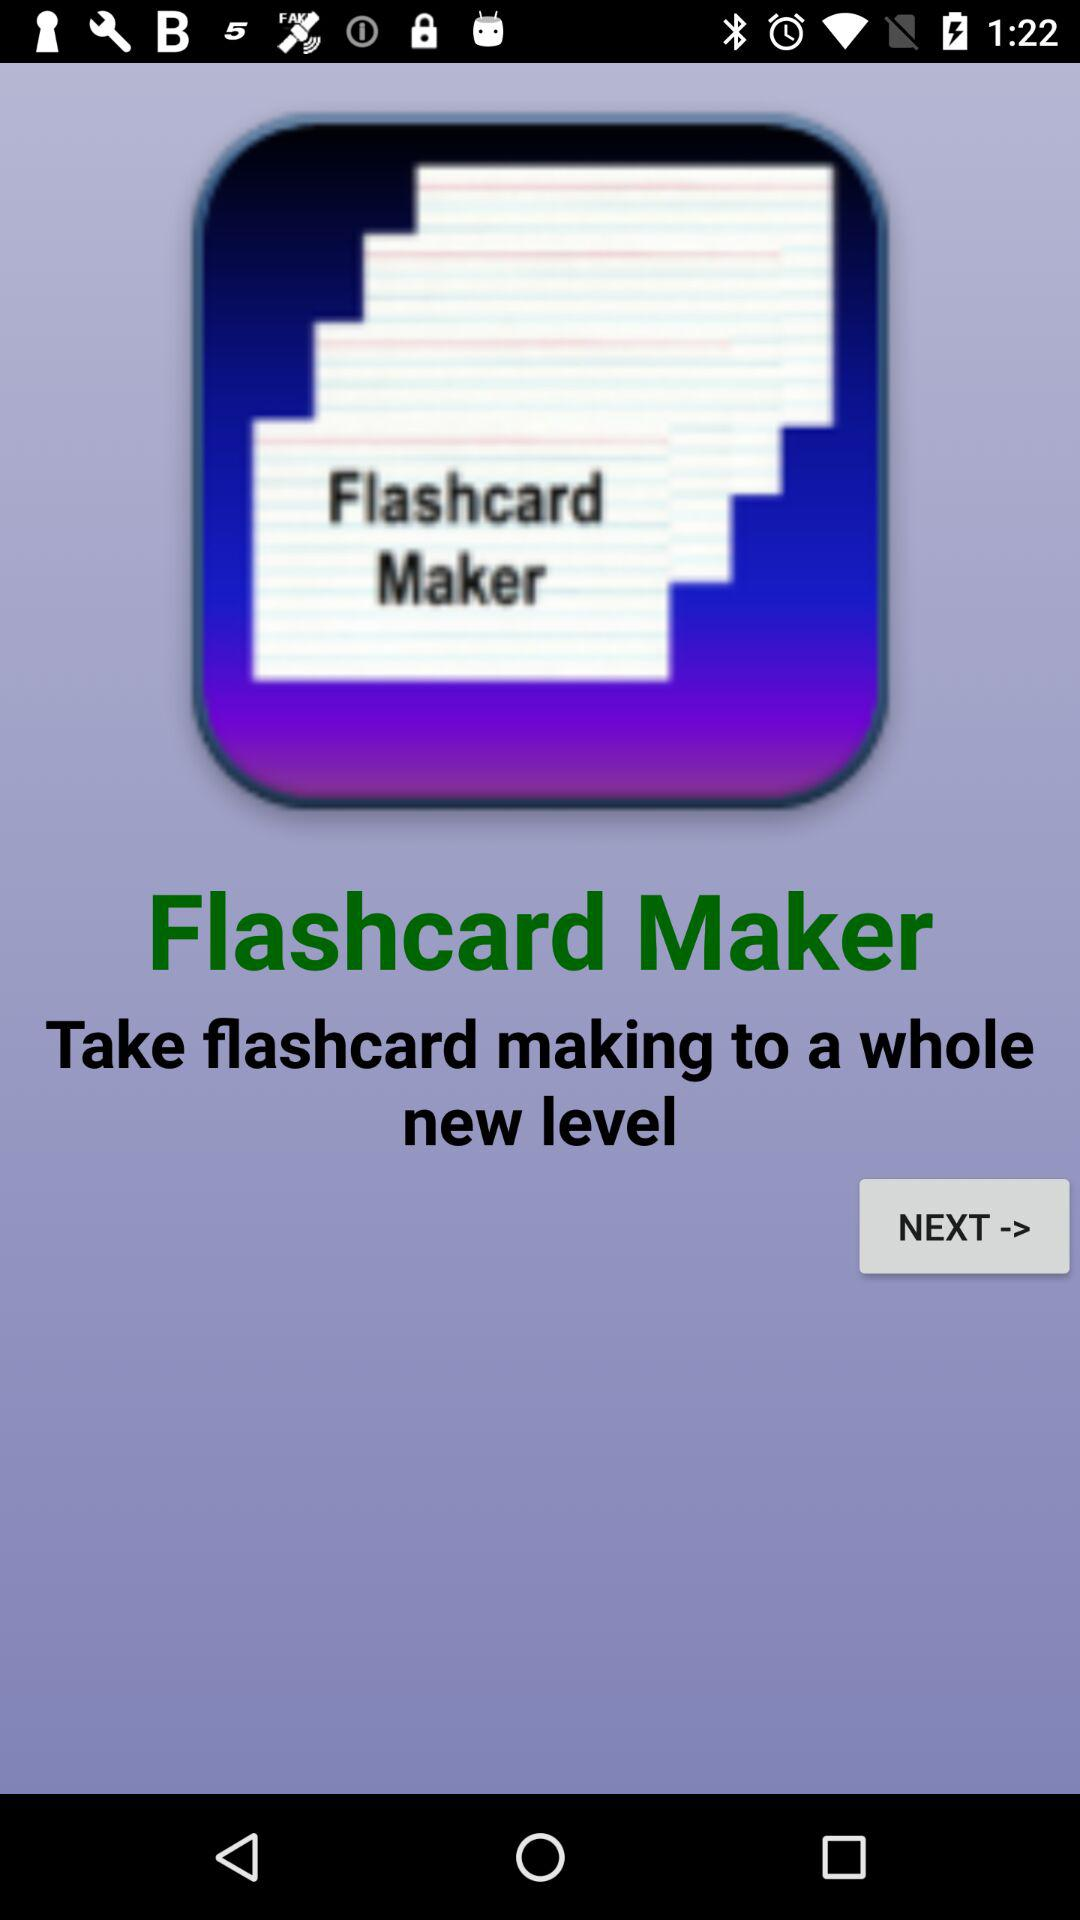What is the application name? The application name is "Flashcard Maker". 